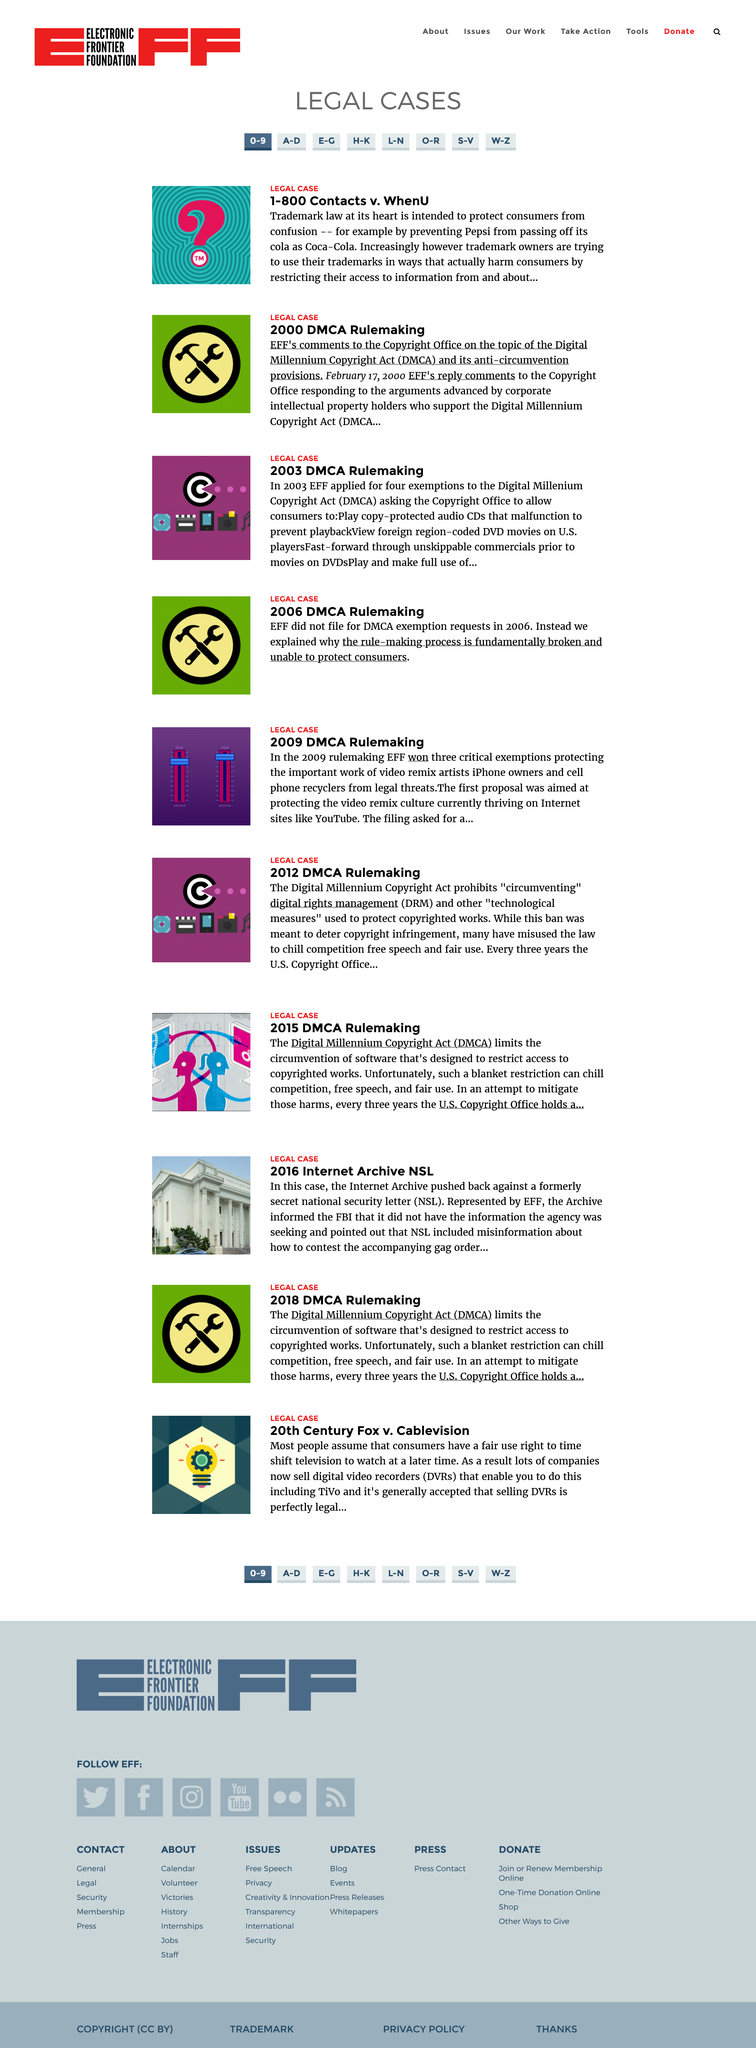Draw attention to some important aspects in this diagram. The acronym DMCA stands for Digital Millennium Copyright Act. It is a federal law in the United States that provides protections for intellectual property rights in the digital age. The purpose of trademark law, which is designed to protect consumers from confusion, is to ensure that consumers are able to identify and distinguish the goods and services of one seller from those of another. The 2003 DMCA rulemaking falls under the legal case category. 